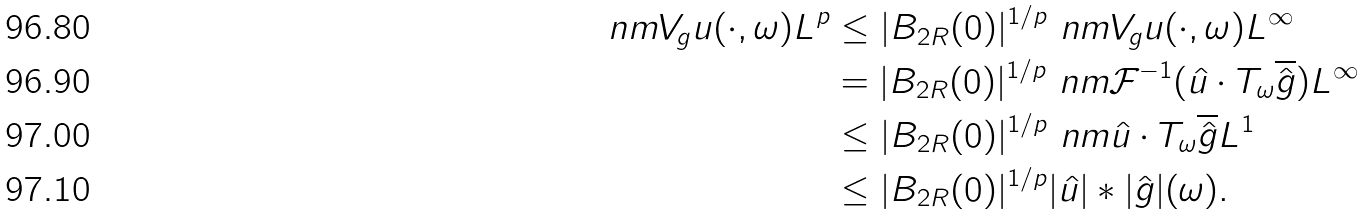Convert formula to latex. <formula><loc_0><loc_0><loc_500><loc_500>\ n m { V _ { g } u ( \cdot , \omega ) } { L ^ { p } } & \leq | B _ { 2 R } ( 0 ) | ^ { 1 / p } \ n m { V _ { g } u ( \cdot , \omega ) } { L ^ { \infty } } \\ & = | B _ { 2 R } ( 0 ) | ^ { 1 / p } \ n m { \mathcal { F } ^ { - 1 } ( \hat { u } \cdot T _ { \omega } \overline { \hat { g } } ) } { L ^ { \infty } } \\ & \leq | B _ { 2 R } ( 0 ) | ^ { 1 / p } \ n m { \hat { u } \cdot T _ { \omega } \overline { \hat { g } } } { L ^ { 1 } } \\ & \leq | B _ { 2 R } ( 0 ) | ^ { 1 / p } | \hat { u } | \ast | \hat { g } | ( \omega ) .</formula> 